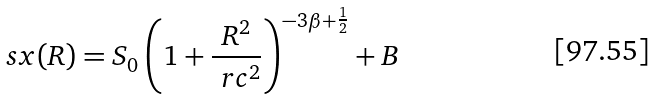<formula> <loc_0><loc_0><loc_500><loc_500>\ s x ( R ) = S _ { 0 } \left ( 1 + \frac { R ^ { 2 } } { \ r c ^ { 2 } } \right ) ^ { - 3 \beta + \frac { 1 } { 2 } } + B</formula> 